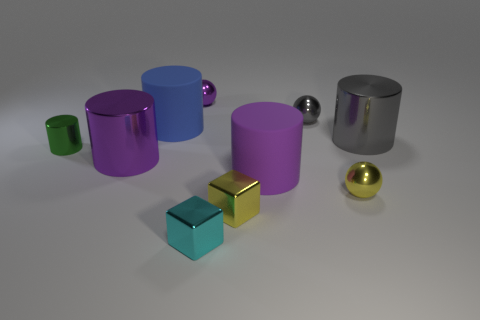Subtract all blue cylinders. How many cylinders are left? 4 Subtract all small green cylinders. How many cylinders are left? 4 Subtract all green cylinders. Subtract all brown spheres. How many cylinders are left? 4 Subtract all spheres. How many objects are left? 7 Add 7 small yellow blocks. How many small yellow blocks exist? 8 Subtract 1 purple spheres. How many objects are left? 9 Subtract all tiny blue shiny things. Subtract all tiny yellow balls. How many objects are left? 9 Add 1 small purple things. How many small purple things are left? 2 